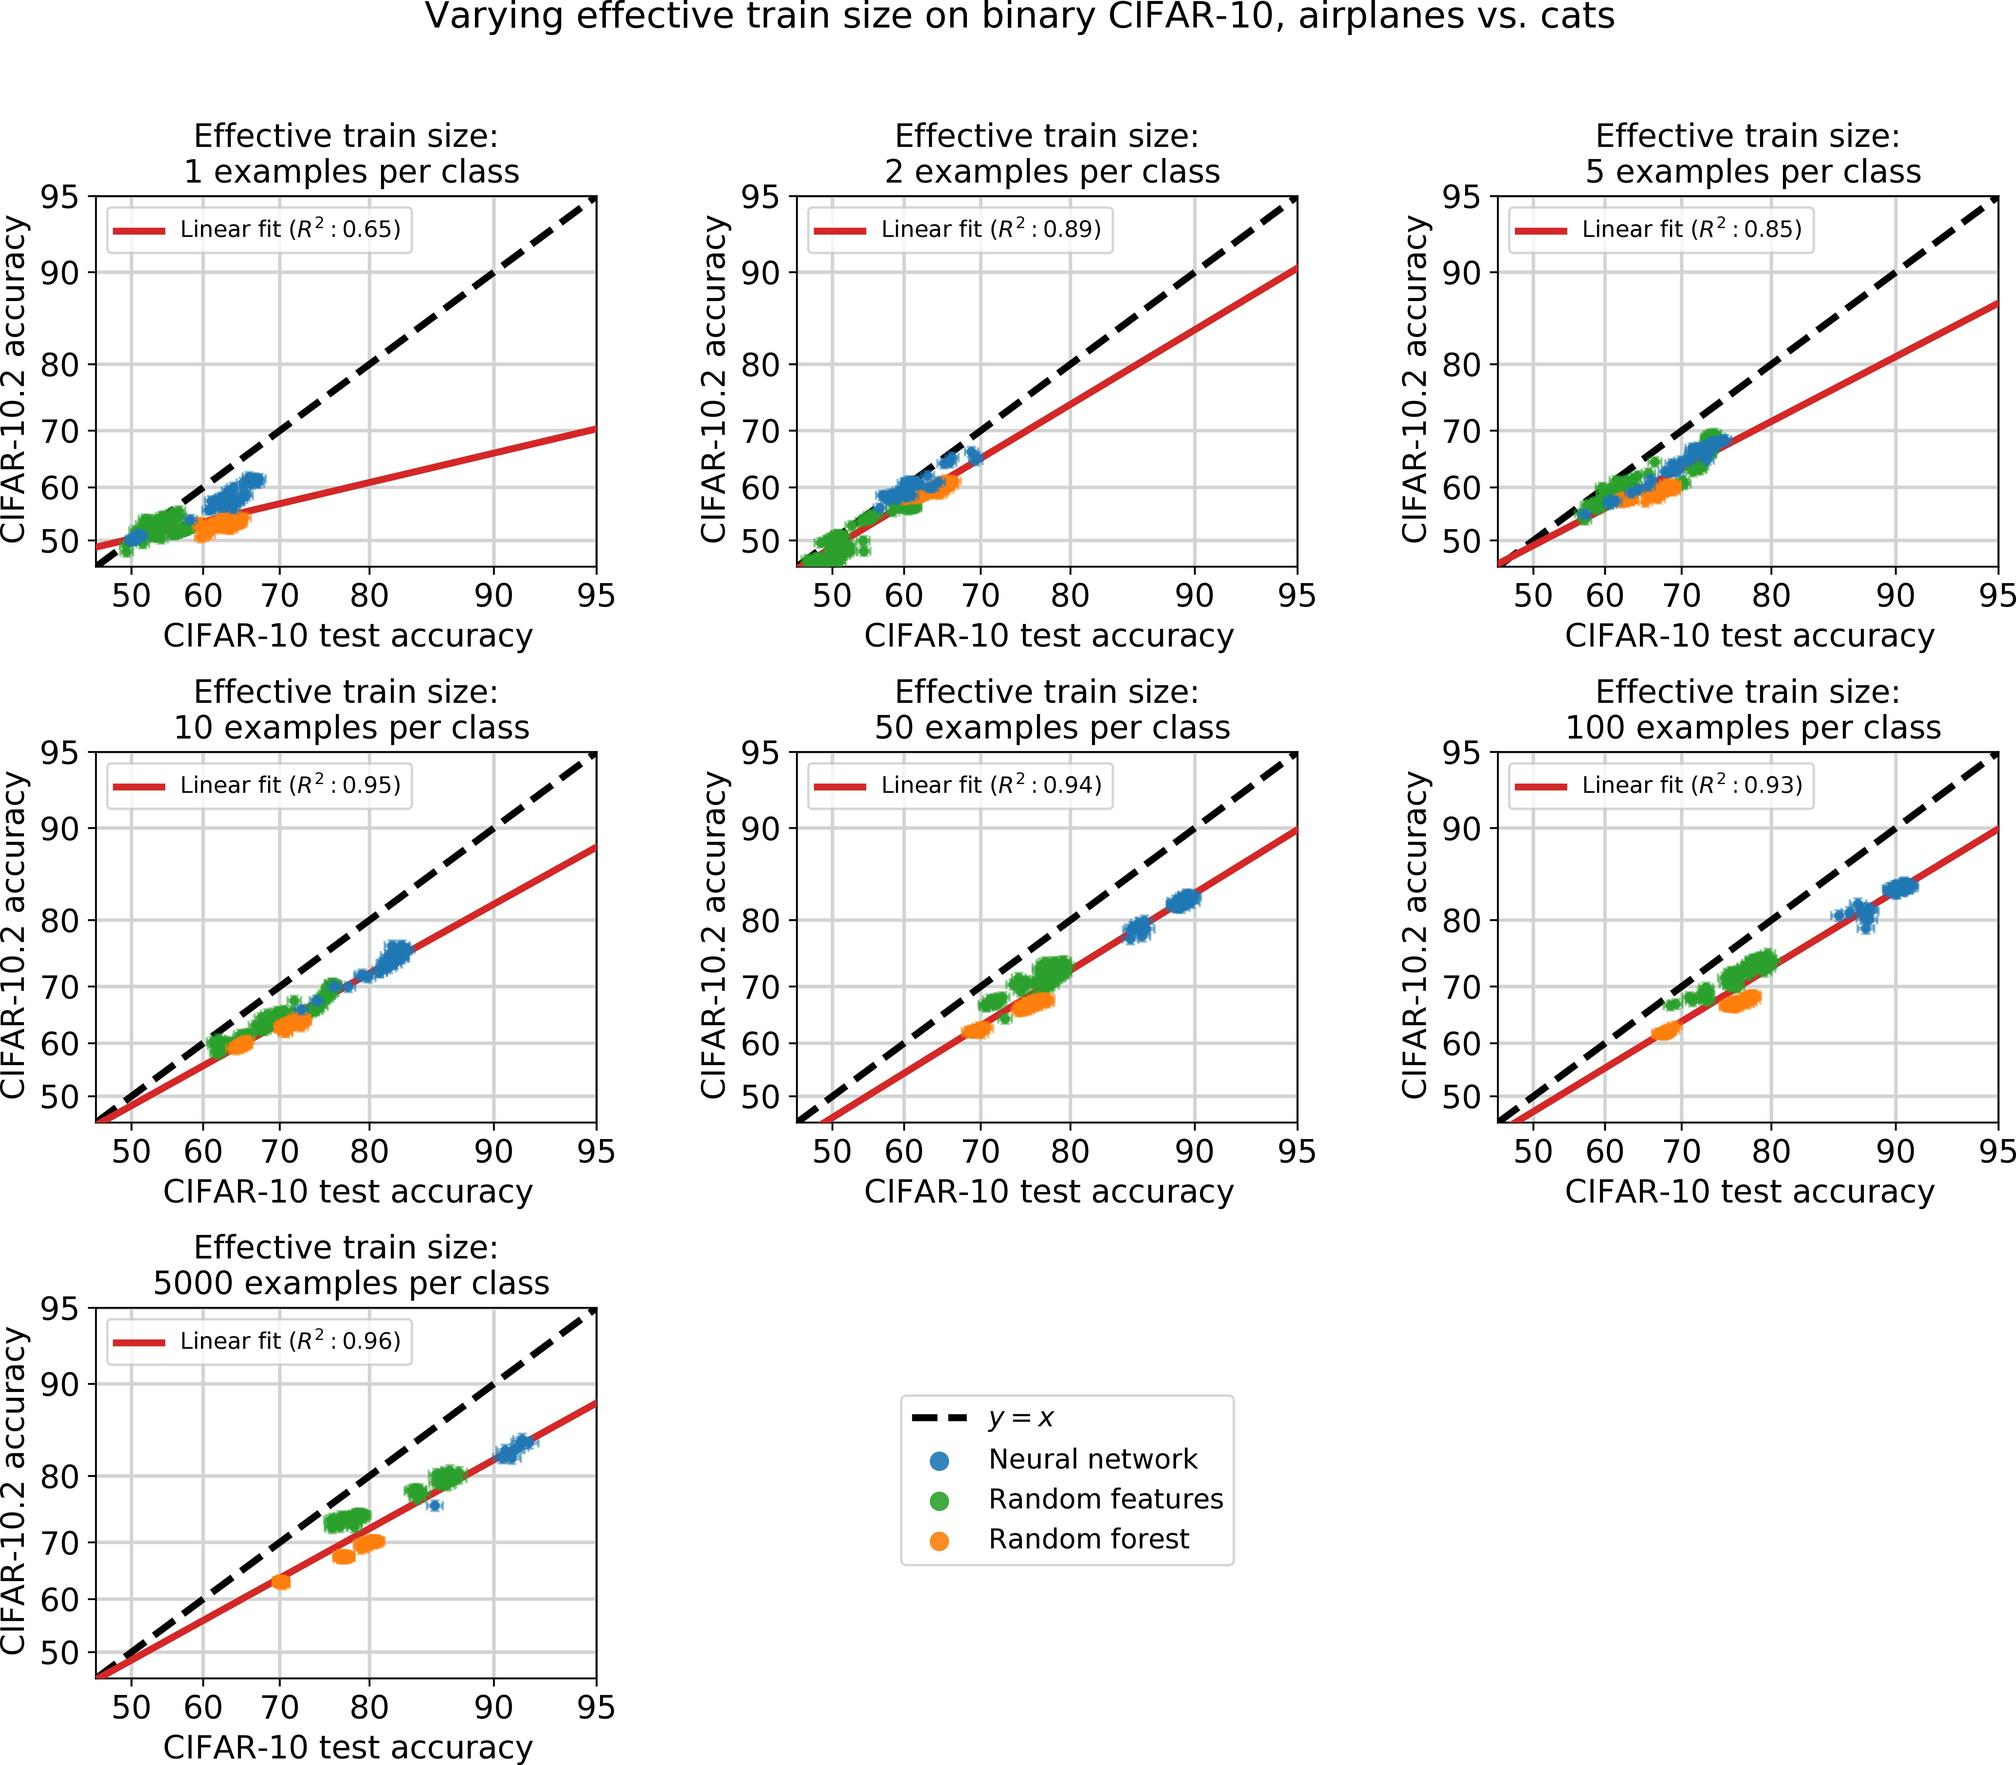How does the test accuracy differ when the training set size is dramatically increased from 50 to 5000 examples per class? The graphs illustrate a significant improvement in test accuracy when the training set size is increased from 50 to 5000 examples per class. For instance, the accuracy jumps from around 60-70% to nearly 90-95% in the neural network model. This highlights the scale's impact, showing that larger datasets greatly enhance the learning capabilities and subsequent performance of the models. 